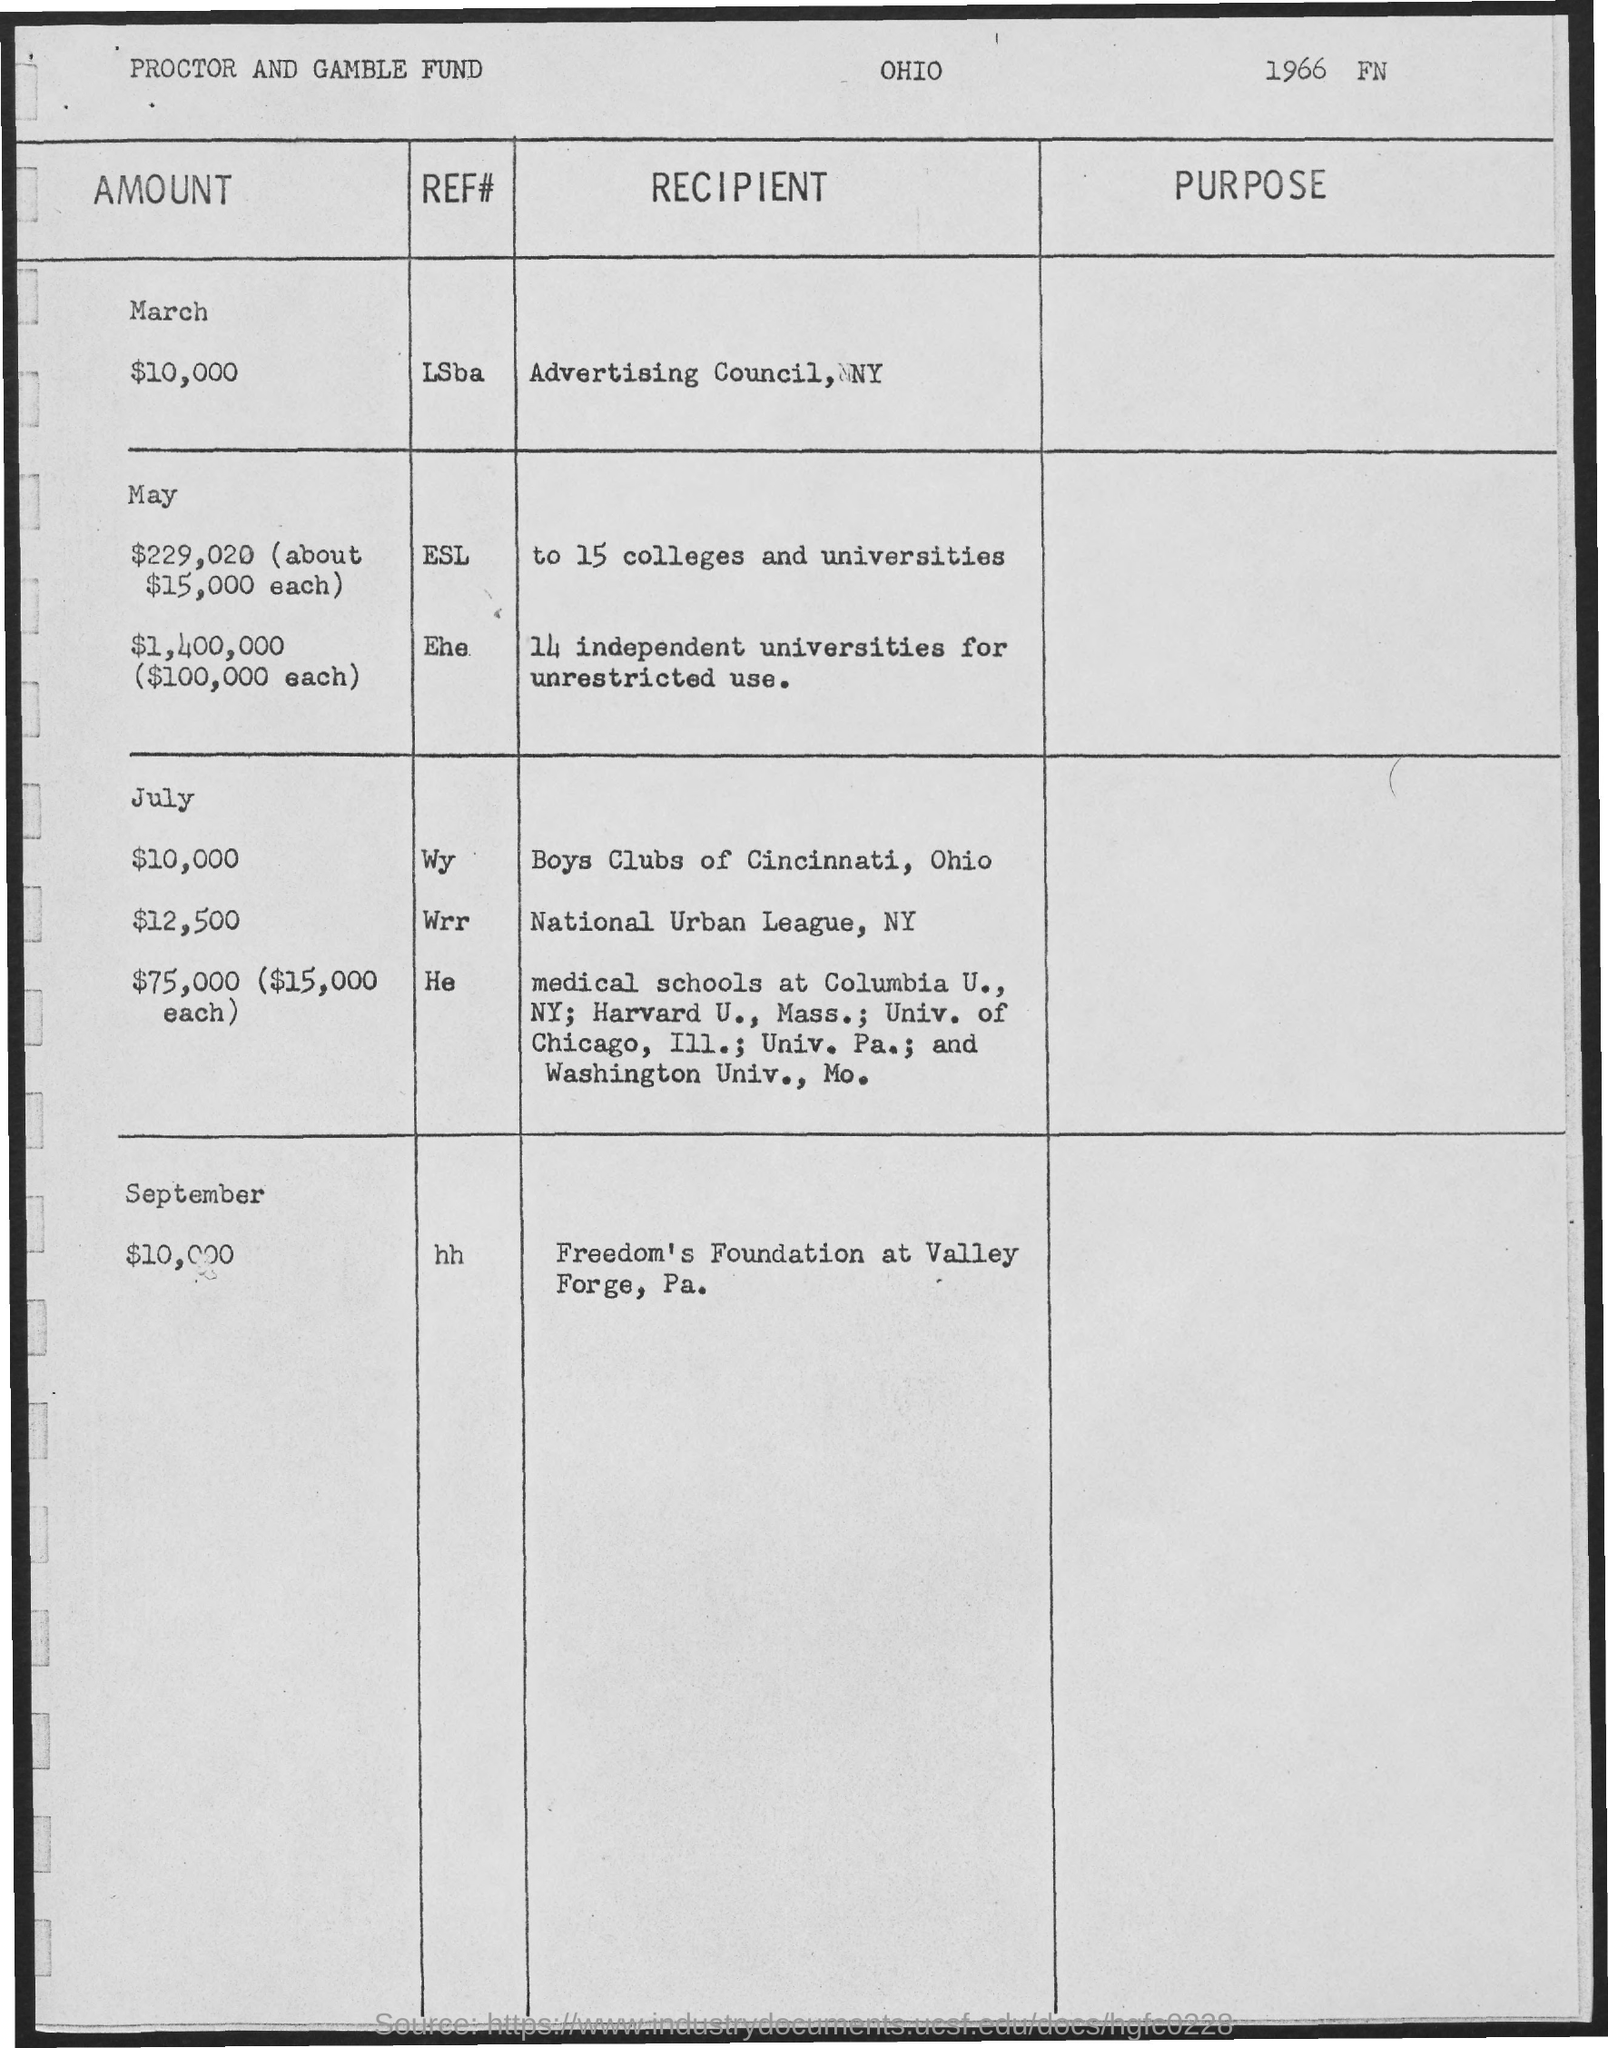Outline some significant characteristics in this image. The document pertains to the Proctor and Gamble Fund, which is the subject of discussion. A grant was provided to 15 colleges and universities in the month of May. Freedom's Foundation at Valley Forge, Pennsylvania, received $10,000 in September. The Advertising Council, located in New York, received an amount of $10,000. 